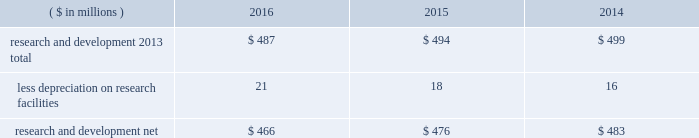Notes to the consolidated financial statements 40 2016 ppg annual report and form 10-k 1 .
Summary of significant accounting policies principles of consolidation the accompanying consolidated financial statements include the accounts of ppg industries , inc .
( 201cppg 201d or the 201ccompany 201d ) and all subsidiaries , both u.s .
And non-u.s. , that it controls .
Ppg owns more than 50% ( 50 % ) of the voting stock of most of the subsidiaries that it controls .
For those consolidated subsidiaries in which the company 2019s ownership is less than 100% ( 100 % ) , the outside shareholders 2019 interests are shown as noncontrolling interests .
Investments in companies in which ppg owns 20% ( 20 % ) to 50% ( 50 % ) of the voting stock and has the ability to exercise significant influence over operating and financial policies of the investee are accounted for using the equity method of accounting .
As a result , ppg 2019s share of the earnings or losses of such equity affiliates is included in the accompanying consolidated statement of income and ppg 2019s share of these companies 2019 shareholders 2019 equity is included in 201cinvestments 201d in the accompanying consolidated balance sheet .
Transactions between ppg and its subsidiaries are eliminated in consolidation .
Use of estimates in the preparation of financial statements the preparation of financial statements in conformity with u.s .
Generally accepted accounting principles requires management to make estimates and assumptions that affect the reported amounts of assets and liabilities and the disclosure of contingent assets and liabilities at the date of the financial statements , as well as the reported amounts of income and expenses during the reporting period .
Such estimates also include the fair value of assets acquired and liabilities assumed resulting from the allocation of the purchase price related to business combinations consummated .
Actual outcomes could differ from those estimates .
Revenue recognition the company recognizes revenue when the earnings process is complete .
Revenue is recognized by all operating segments when goods are shipped and title to inventory and risk of loss passes to the customer or when services have been rendered .
Shipping and handling costs amounts billed to customers for shipping and handling are reported in 201cnet sales 201d in the accompanying consolidated statement of income .
Shipping and handling costs incurred by the company for the delivery of goods to customers are included in 201ccost of sales , exclusive of depreciation and amortization 201d in the accompanying consolidated statement of income .
Selling , general and administrative costs amounts presented as 201cselling , general and administrative 201d in the accompanying consolidated statement of income are comprised of selling , customer service , distribution and advertising costs , as well as the costs of providing corporate- wide functional support in such areas as finance , law , human resources and planning .
Distribution costs pertain to the movement and storage of finished goods inventory at company- owned and leased warehouses and other distribution facilities .
Advertising costs advertising costs are expensed as incurred and totaled $ 322 million , $ 324 million and $ 297 million in 2016 , 2015 and 2014 , respectively .
Research and development research and development costs , which consist primarily of employee related costs , are charged to expense as incurred. .
Legal costs legal costs , primarily include costs associated with acquisition and divestiture transactions , general litigation , environmental regulation compliance , patent and trademark protection and other general corporate purposes , are charged to expense as incurred .
Foreign currency translation the functional currency of most significant non-u.s .
Operations is their local currency .
Assets and liabilities of those operations are translated into u.s .
Dollars using year-end exchange rates ; income and expenses are translated using the average exchange rates for the reporting period .
Unrealized foreign currency translation adjustments are deferred in accumulated other comprehensive loss , a separate component of shareholders 2019 equity .
Cash equivalents cash equivalents are highly liquid investments ( valued at cost , which approximates fair value ) acquired with an original maturity of three months or less .
Short-term investments short-term investments are highly liquid , high credit quality investments ( valued at cost plus accrued interest ) that have stated maturities of greater than three months to one year .
The purchases and sales of these investments are classified as investing activities in the consolidated statement of cash flows .
Marketable equity securities the company 2019s investment in marketable equity securities is recorded at fair market value and reported in 201cother current assets 201d and 201cinvestments 201d in the accompanying consolidated balance sheet with changes in fair market value recorded in income for those securities designated as trading securities and in other comprehensive income , net of tax , for those designated as available for sale securities. .
Are r&d expenses greater than advertising costs in 2015? 
Computations: (494 > 324)
Answer: yes. 